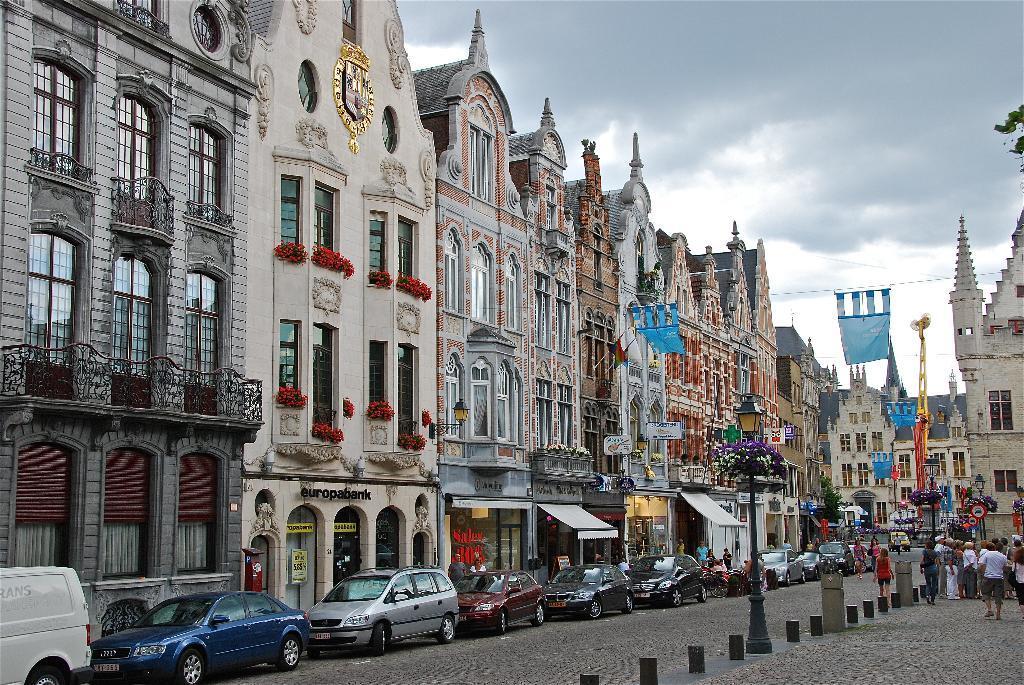How would you summarize this image in a sentence or two? This is the picture of a city. In this image there are vehicles on the road and there are group of people walking on the road. At the back there are buildings and flags. In the foreground there are poles. At the top there is sky and there are clouds. At the bottom there is a road. 